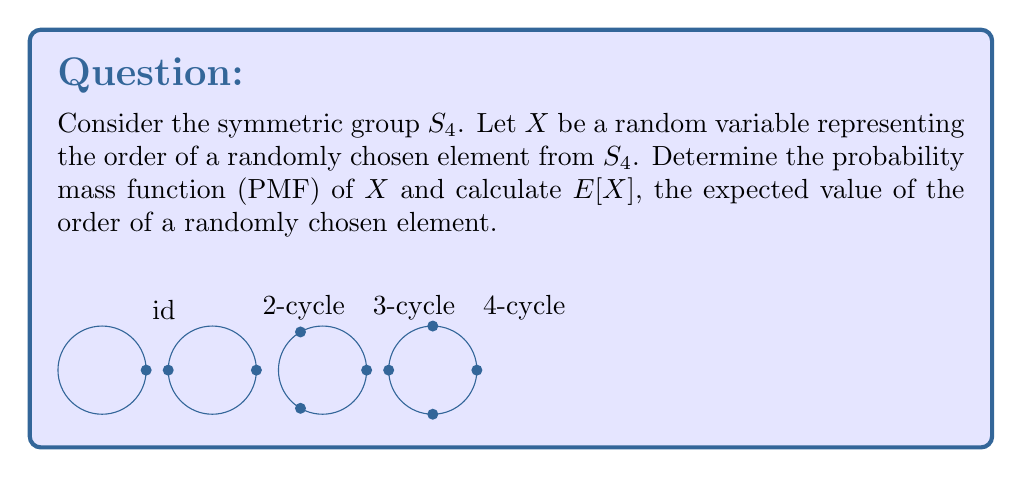Can you solve this math problem? To solve this problem, we need to follow these steps:

1) First, let's count the elements of each order in $S_4$:

   - Order 1: Only the identity element (1)
   - Order 2: Transpositions (6) and products of two disjoint transpositions (3), total 9
   - Order 3: 3-cycles (8)
   - Order 4: 4-cycles (6)

2) The total number of elements in $S_4$ is $4! = 24$

3) Now we can determine the PMF of $X$:

   $P(X = 1) = \frac{1}{24}$
   $P(X = 2) = \frac{9}{24} = \frac{3}{8}$
   $P(X = 3) = \frac{8}{24} = \frac{1}{3}$
   $P(X = 4) = \frac{6}{24} = \frac{1}{4}$

4) To calculate $E[X]$, we use the formula:

   $E[X] = \sum_{x} x \cdot P(X = x)$

   $E[X] = 1 \cdot \frac{1}{24} + 2 \cdot \frac{3}{8} + 3 \cdot \frac{1}{3} + 4 \cdot \frac{1}{4}$

   $E[X] = \frac{1}{24} + \frac{3}{4} + 1 + 1 = \frac{65}{24} \approx 2.71$

Therefore, the PMF of $X$ is as given in step 3, and the expected order of a randomly chosen element from $S_4$ is $\frac{65}{24}$.
Answer: PMF: $P(X = 1) = \frac{1}{24}$, $P(X = 2) = \frac{3}{8}$, $P(X = 3) = \frac{1}{3}$, $P(X = 4) = \frac{1}{4}$. $E[X] = \frac{65}{24}$. 